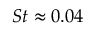<formula> <loc_0><loc_0><loc_500><loc_500>S t \approx 0 . 0 4</formula> 